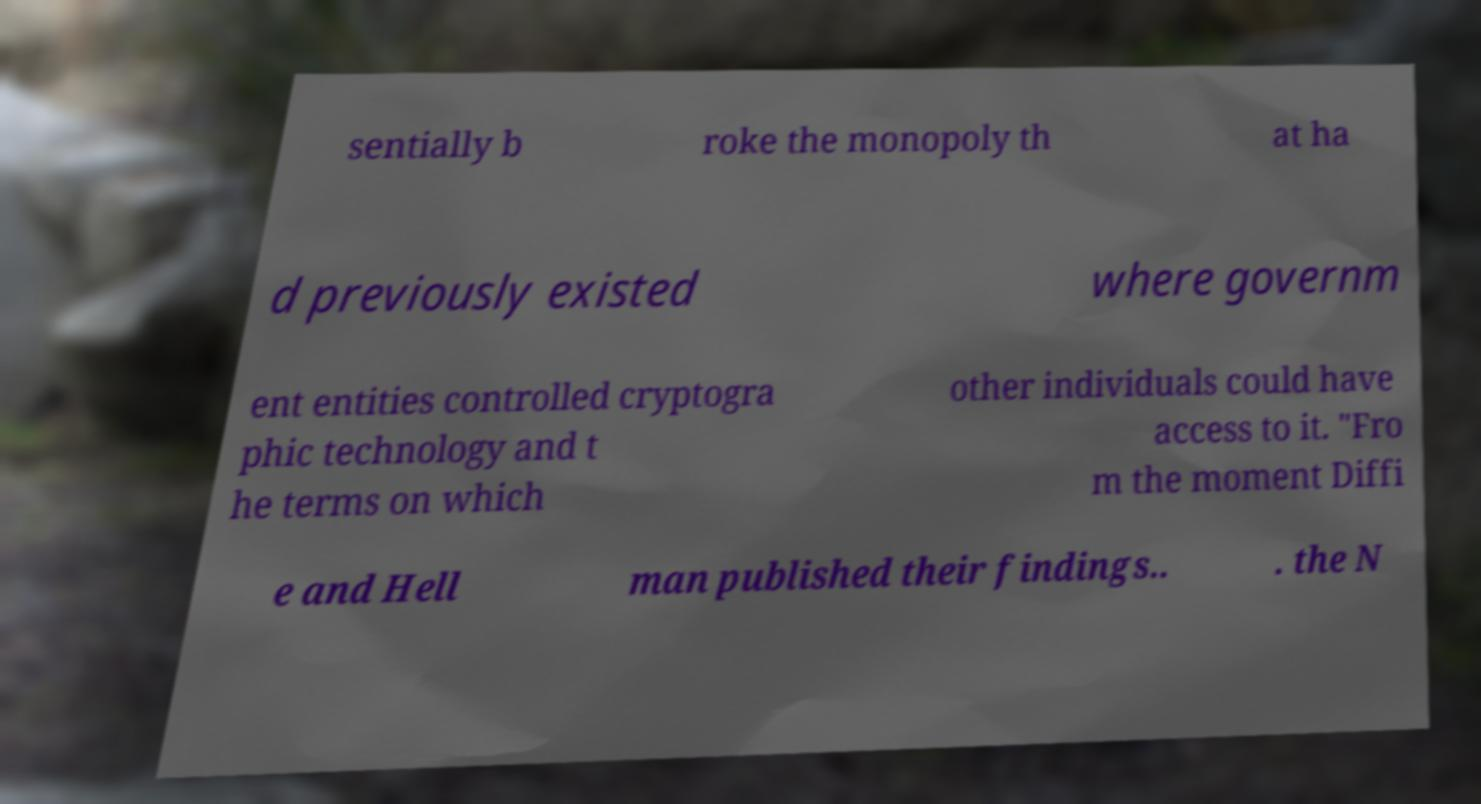Please identify and transcribe the text found in this image. sentially b roke the monopoly th at ha d previously existed where governm ent entities controlled cryptogra phic technology and t he terms on which other individuals could have access to it. "Fro m the moment Diffi e and Hell man published their findings.. . the N 